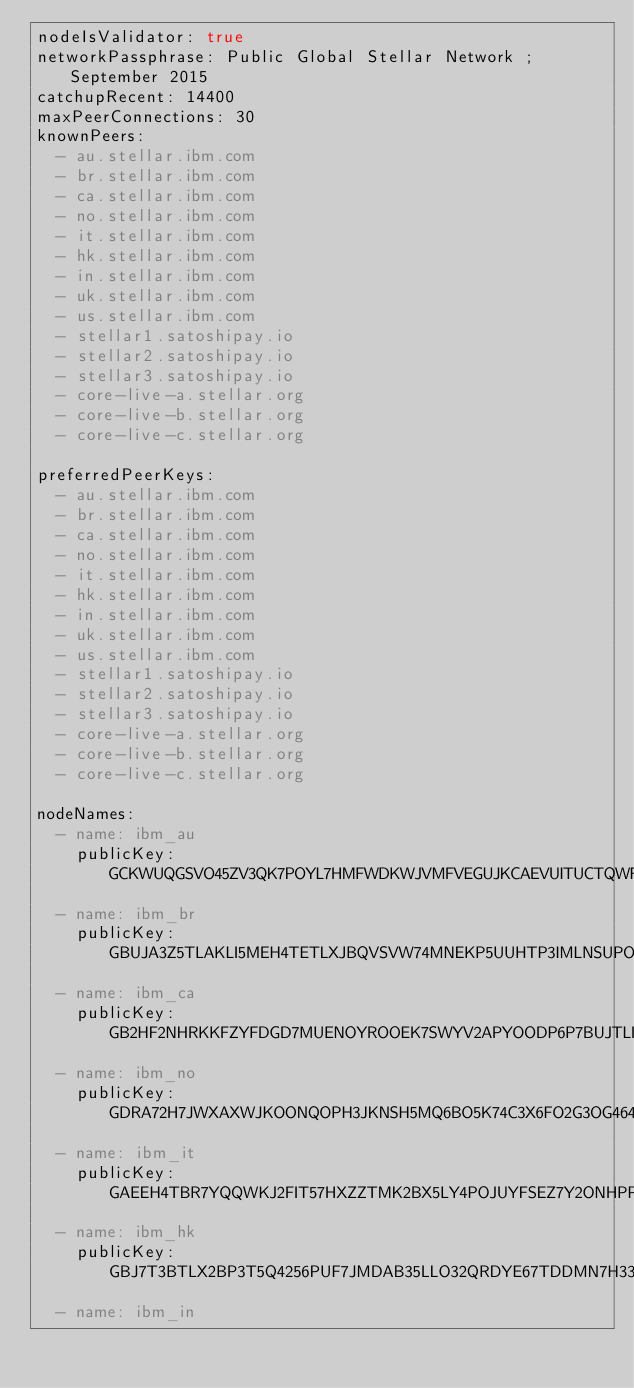Convert code to text. <code><loc_0><loc_0><loc_500><loc_500><_YAML_>nodeIsValidator: true
networkPassphrase: Public Global Stellar Network ; September 2015
catchupRecent: 14400
maxPeerConnections: 30
knownPeers:
  - au.stellar.ibm.com
  - br.stellar.ibm.com
  - ca.stellar.ibm.com
  - no.stellar.ibm.com
  - it.stellar.ibm.com
  - hk.stellar.ibm.com
  - in.stellar.ibm.com
  - uk.stellar.ibm.com
  - us.stellar.ibm.com
  - stellar1.satoshipay.io
  - stellar2.satoshipay.io
  - stellar3.satoshipay.io
  - core-live-a.stellar.org
  - core-live-b.stellar.org
  - core-live-c.stellar.org

preferredPeerKeys:
  - au.stellar.ibm.com
  - br.stellar.ibm.com
  - ca.stellar.ibm.com
  - no.stellar.ibm.com
  - it.stellar.ibm.com
  - hk.stellar.ibm.com
  - in.stellar.ibm.com
  - uk.stellar.ibm.com
  - us.stellar.ibm.com
  - stellar1.satoshipay.io
  - stellar2.satoshipay.io
  - stellar3.satoshipay.io
  - core-live-a.stellar.org
  - core-live-b.stellar.org
  - core-live-c.stellar.org

nodeNames:
  - name: ibm_au
    publicKey: GCKWUQGSVO45ZV3QK7POYL7HMFWDKWJVMFVEGUJKCAEVUITUCTQWFSM6
  - name: ibm_br
    publicKey: GBUJA3Z5TLAKLI5MEH4TETLXJBQVSVW74MNEKP5UUHTP3IMLNSUPOTVA
  - name: ibm_ca
    publicKey: GB2HF2NHRKKFZYFDGD7MUENOYROOEK7SWYV2APYOODP6P7BUJTLILKIL
  - name: ibm_no
    publicKey: GDRA72H7JWXAXWJKOONQOPH3JKNSH5MQ6BO5K74C3X6FO2G3OG464BPU
  - name: ibm_it
    publicKey: GAEEH4TBR7YQQWKJ2FIT57HXZZTMK2BX5LY4POJUYFSEZ7Y2ONHPPTES
  - name: ibm_hk
    publicKey: GBJ7T3BTLX2BP3T5Q4256PUF7JMDAB35LLO32QRDYE67TDDMN7H33GGE
  - name: ibm_in</code> 